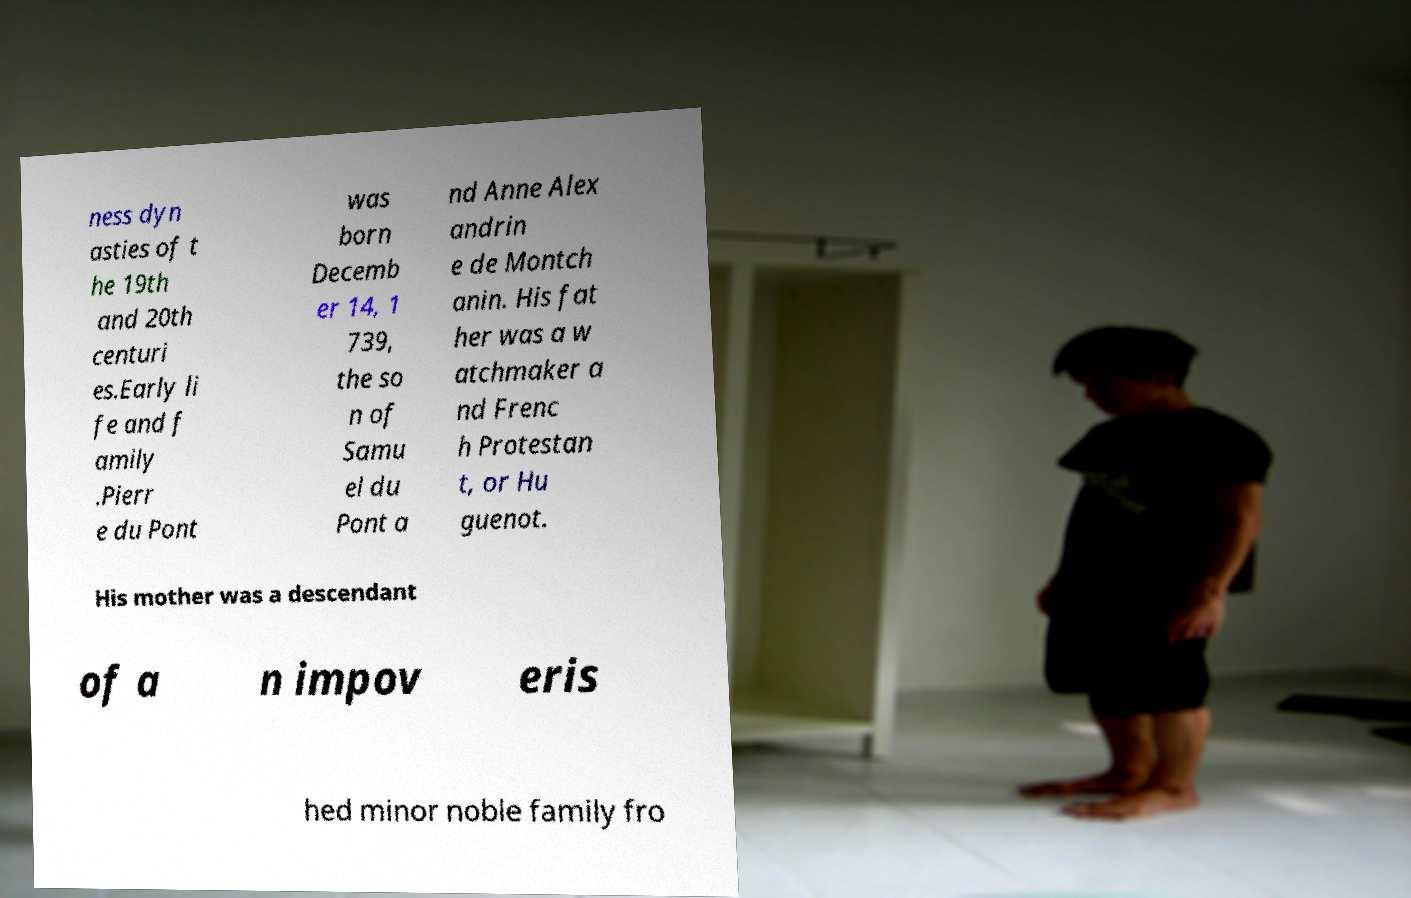Could you extract and type out the text from this image? ness dyn asties of t he 19th and 20th centuri es.Early li fe and f amily .Pierr e du Pont was born Decemb er 14, 1 739, the so n of Samu el du Pont a nd Anne Alex andrin e de Montch anin. His fat her was a w atchmaker a nd Frenc h Protestan t, or Hu guenot. His mother was a descendant of a n impov eris hed minor noble family fro 